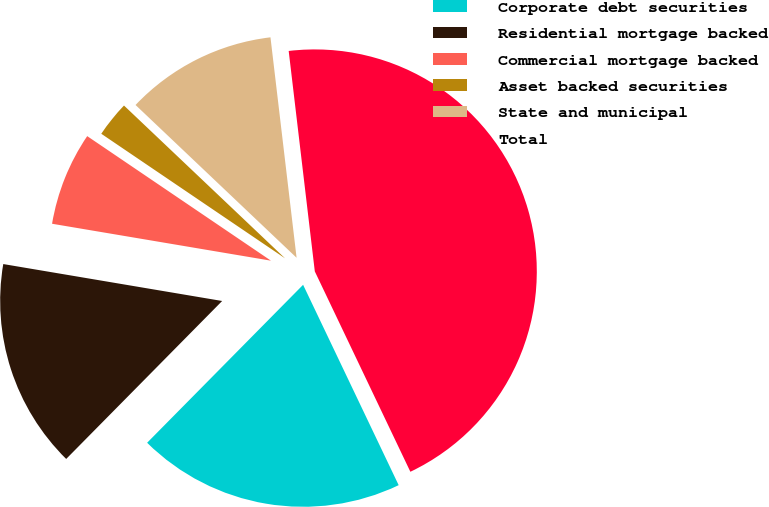Convert chart. <chart><loc_0><loc_0><loc_500><loc_500><pie_chart><fcel>Corporate debt securities<fcel>Residential mortgage backed<fcel>Commercial mortgage backed<fcel>Asset backed securities<fcel>State and municipal<fcel>Total<nl><fcel>19.48%<fcel>15.26%<fcel>6.82%<fcel>2.6%<fcel>11.04%<fcel>44.79%<nl></chart> 